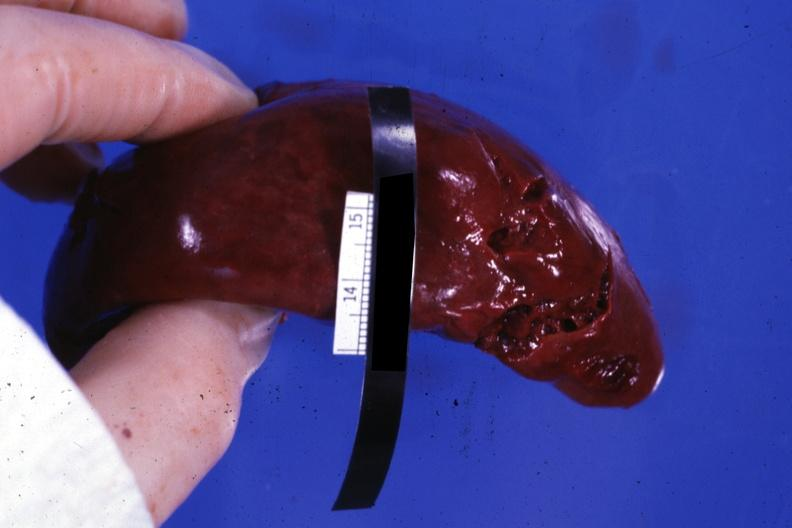what does this image show?
Answer the question using a single word or phrase. External view with several tears in capsule 